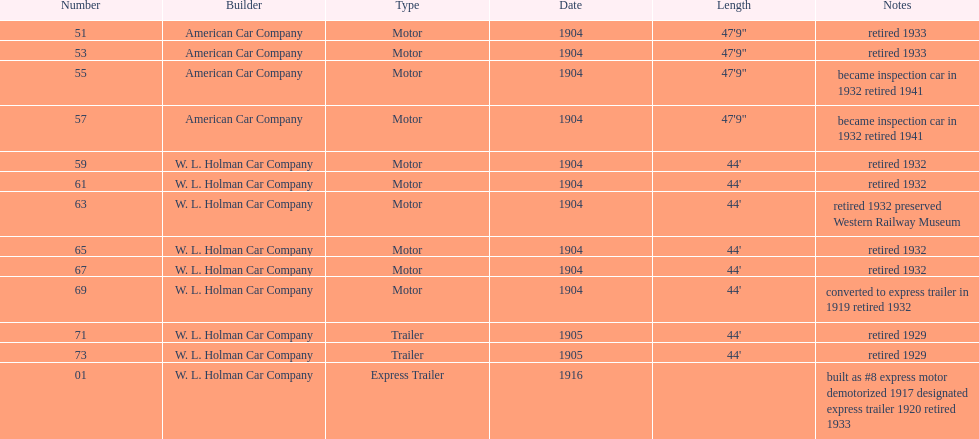What was the total number of cars listed? 13. 